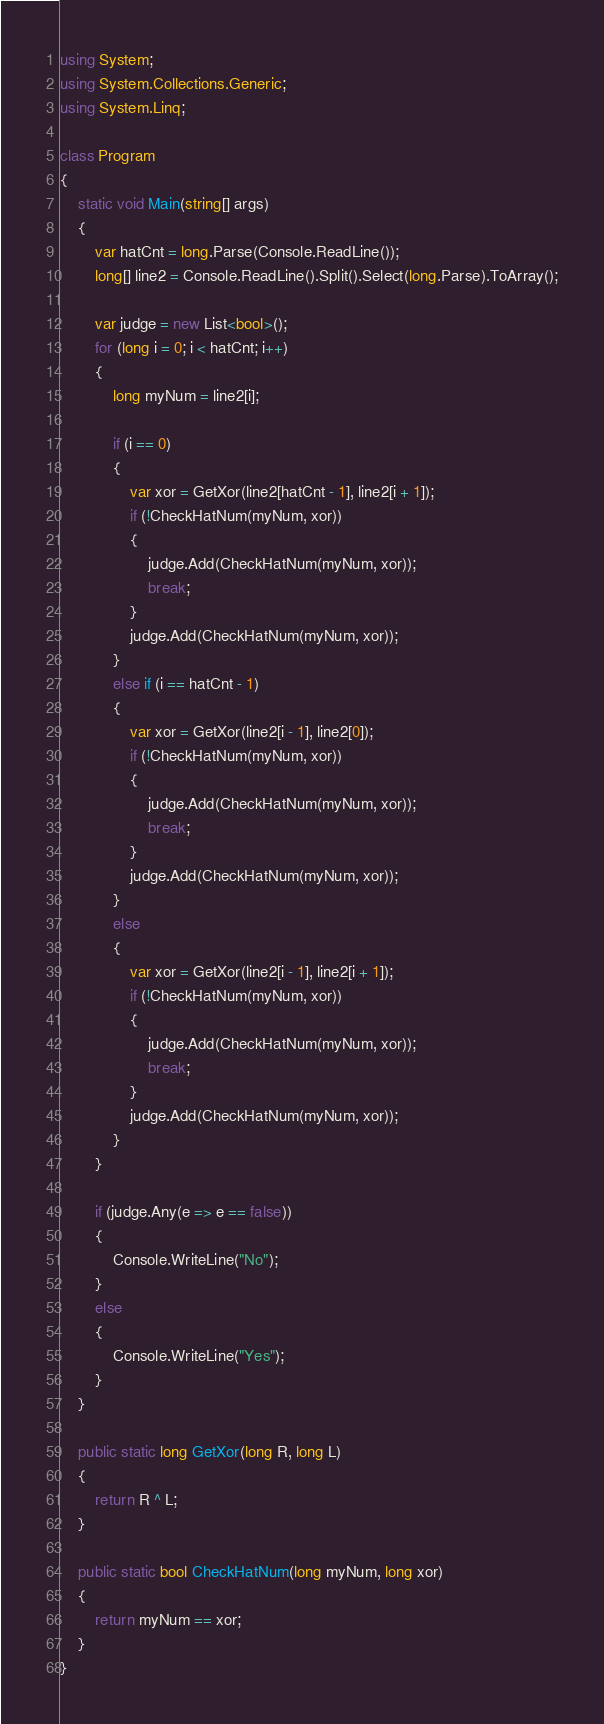Convert code to text. <code><loc_0><loc_0><loc_500><loc_500><_C#_>using System;
using System.Collections.Generic;
using System.Linq;

class Program
{
    static void Main(string[] args)
    {
        var hatCnt = long.Parse(Console.ReadLine());
        long[] line2 = Console.ReadLine().Split().Select(long.Parse).ToArray();

        var judge = new List<bool>();
        for (long i = 0; i < hatCnt; i++)
        {
            long myNum = line2[i];

            if (i == 0)
            {
                var xor = GetXor(line2[hatCnt - 1], line2[i + 1]);
                if (!CheckHatNum(myNum, xor))
                {
                    judge.Add(CheckHatNum(myNum, xor));
                    break;
                }
                judge.Add(CheckHatNum(myNum, xor));
            }
            else if (i == hatCnt - 1)
            {
                var xor = GetXor(line2[i - 1], line2[0]);
                if (!CheckHatNum(myNum, xor))
                {
                    judge.Add(CheckHatNum(myNum, xor));
                    break;
                }
                judge.Add(CheckHatNum(myNum, xor));
            }
            else
            {
                var xor = GetXor(line2[i - 1], line2[i + 1]);
                if (!CheckHatNum(myNum, xor))
                {
                    judge.Add(CheckHatNum(myNum, xor));
                    break;
                }
                judge.Add(CheckHatNum(myNum, xor));
            }
        }

        if (judge.Any(e => e == false))
        {
            Console.WriteLine("No");
        }
        else
        {
            Console.WriteLine("Yes");
        }
    }

    public static long GetXor(long R, long L)
    {
        return R ^ L;
    }

    public static bool CheckHatNum(long myNum, long xor)
    {
        return myNum == xor;
    }
}
</code> 